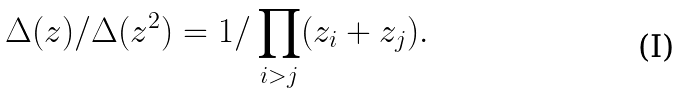Convert formula to latex. <formula><loc_0><loc_0><loc_500><loc_500>\Delta ( z ) / \Delta ( z ^ { 2 } ) = 1 / \prod _ { i > j } ( z _ { i } + z _ { j } ) .</formula> 